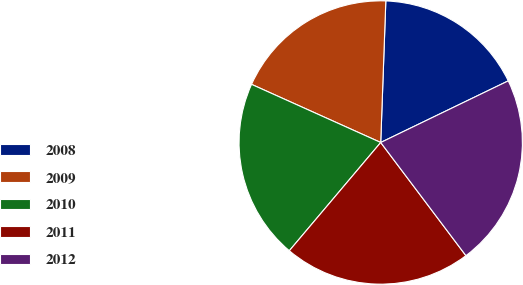Convert chart. <chart><loc_0><loc_0><loc_500><loc_500><pie_chart><fcel>2008<fcel>2009<fcel>2010<fcel>2011<fcel>2012<nl><fcel>17.26%<fcel>18.84%<fcel>20.57%<fcel>21.43%<fcel>21.89%<nl></chart> 